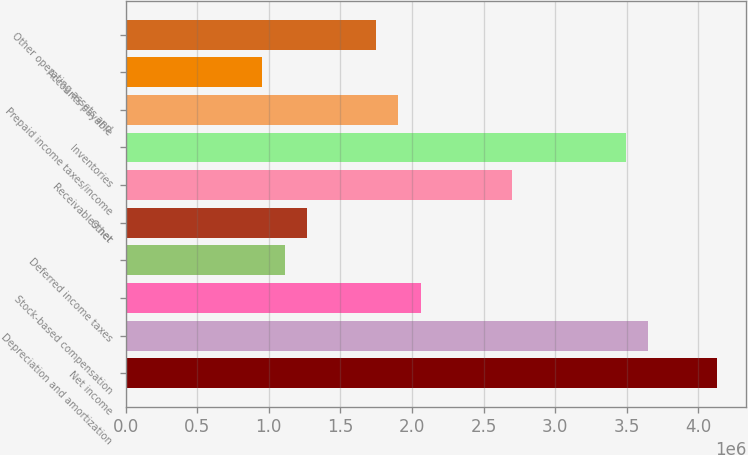Convert chart. <chart><loc_0><loc_0><loc_500><loc_500><bar_chart><fcel>Net income<fcel>Depreciation and amortization<fcel>Stock-based compensation<fcel>Deferred income taxes<fcel>Other<fcel>Receivables net<fcel>Inventories<fcel>Prepaid income taxes/income<fcel>Accounts payable<fcel>Other operating assets and<nl><fcel>4.12763e+06<fcel>3.65139e+06<fcel>2.06389e+06<fcel>1.1114e+06<fcel>1.27015e+06<fcel>2.69889e+06<fcel>3.49264e+06<fcel>1.90514e+06<fcel>952646<fcel>1.74639e+06<nl></chart> 